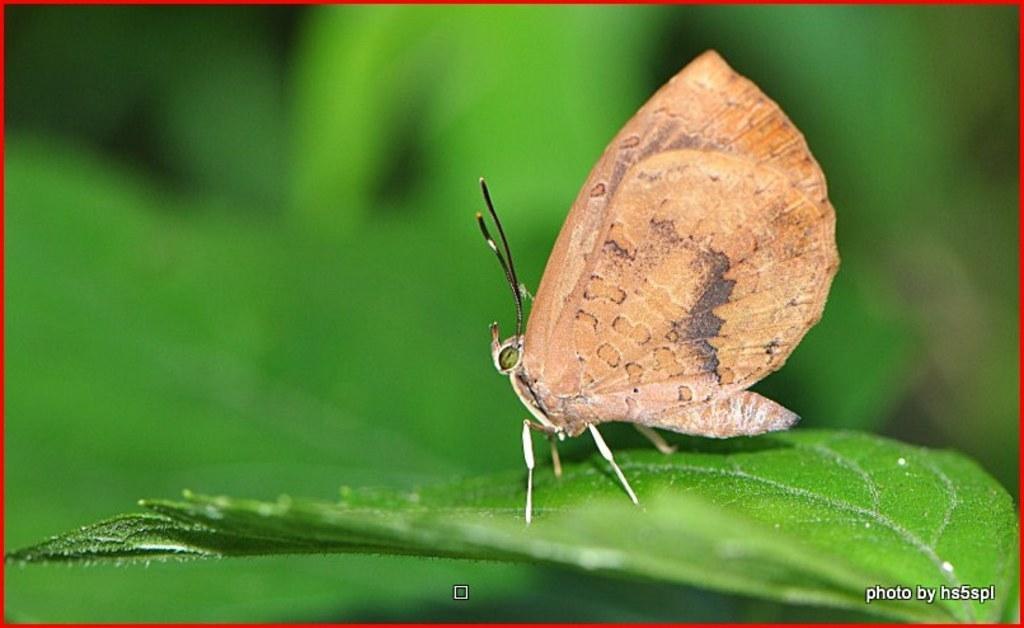What can be found in the bottom right corner of the image? There is a watermark in the bottom right corner of the image. What is the butterfly doing in the image? The butterfly is on a green leaf on the right side of the image. How would you describe the background of the image? The background of the image is blurred. What type of bulb is illuminating the town in the image? There is no town or bulb present in the image; it features a butterfly on a green leaf with a blurred background. 